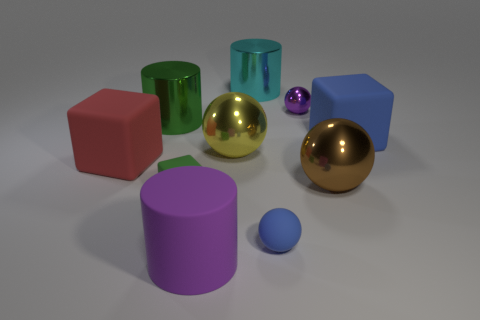Which objects in the image appear to be reflective? The objects that show reflectivity are the two spheres: one gold and one silver. They have a high gloss finish that mirrors their surroundings. 